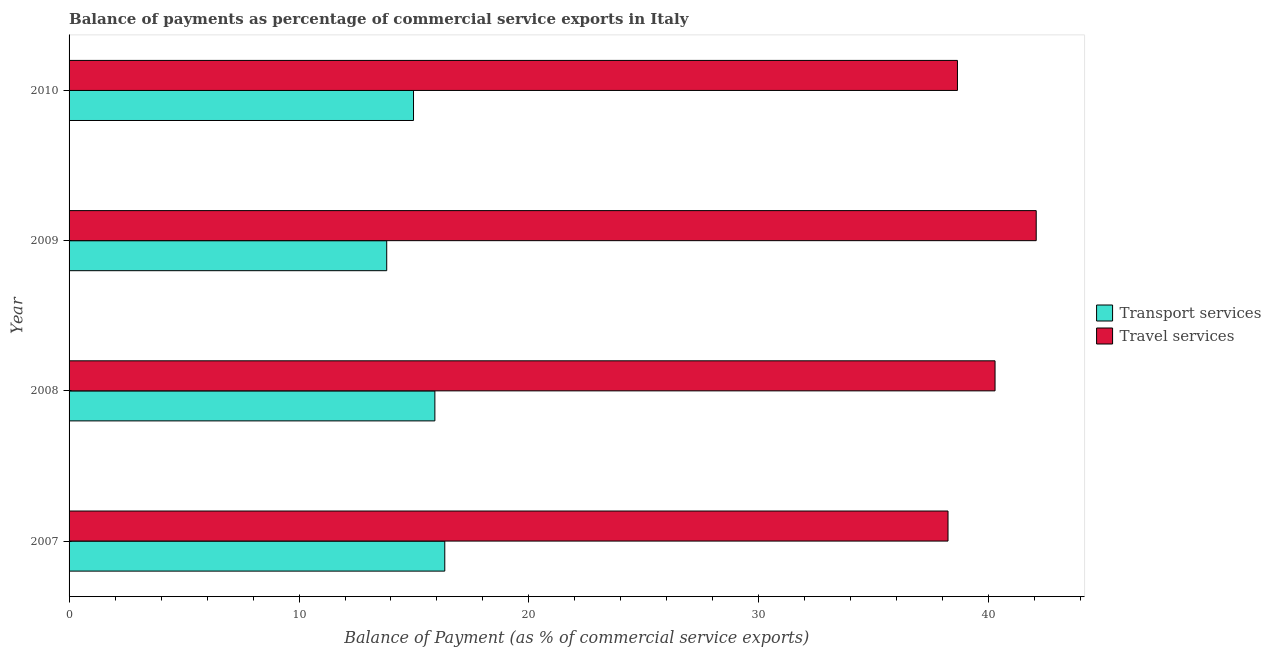How many different coloured bars are there?
Your answer should be compact. 2. How many groups of bars are there?
Your answer should be compact. 4. Are the number of bars per tick equal to the number of legend labels?
Your response must be concise. Yes. How many bars are there on the 2nd tick from the top?
Your answer should be compact. 2. How many bars are there on the 3rd tick from the bottom?
Provide a succinct answer. 2. What is the label of the 1st group of bars from the top?
Keep it short and to the point. 2010. What is the balance of payments of transport services in 2008?
Provide a short and direct response. 15.91. Across all years, what is the maximum balance of payments of travel services?
Provide a short and direct response. 42.06. Across all years, what is the minimum balance of payments of travel services?
Your answer should be compact. 38.22. What is the total balance of payments of travel services in the graph?
Give a very brief answer. 159.19. What is the difference between the balance of payments of transport services in 2007 and that in 2009?
Provide a short and direct response. 2.52. What is the difference between the balance of payments of travel services in 2008 and the balance of payments of transport services in 2007?
Your response must be concise. 23.93. What is the average balance of payments of transport services per year?
Make the answer very short. 15.26. In the year 2009, what is the difference between the balance of payments of travel services and balance of payments of transport services?
Provide a short and direct response. 28.25. In how many years, is the balance of payments of travel services greater than 6 %?
Offer a very short reply. 4. What is the ratio of the balance of payments of transport services in 2007 to that in 2009?
Make the answer very short. 1.18. What is the difference between the highest and the second highest balance of payments of travel services?
Offer a very short reply. 1.79. What is the difference between the highest and the lowest balance of payments of transport services?
Ensure brevity in your answer.  2.53. What does the 2nd bar from the top in 2010 represents?
Your answer should be compact. Transport services. What does the 1st bar from the bottom in 2010 represents?
Provide a succinct answer. Transport services. How many years are there in the graph?
Your answer should be very brief. 4. What is the difference between two consecutive major ticks on the X-axis?
Ensure brevity in your answer.  10. Are the values on the major ticks of X-axis written in scientific E-notation?
Ensure brevity in your answer.  No. Does the graph contain grids?
Your answer should be compact. No. Where does the legend appear in the graph?
Give a very brief answer. Center right. How are the legend labels stacked?
Provide a succinct answer. Vertical. What is the title of the graph?
Give a very brief answer. Balance of payments as percentage of commercial service exports in Italy. Does "Travel Items" appear as one of the legend labels in the graph?
Offer a terse response. No. What is the label or title of the X-axis?
Offer a very short reply. Balance of Payment (as % of commercial service exports). What is the label or title of the Y-axis?
Offer a very short reply. Year. What is the Balance of Payment (as % of commercial service exports) of Transport services in 2007?
Provide a short and direct response. 16.34. What is the Balance of Payment (as % of commercial service exports) in Travel services in 2007?
Your answer should be compact. 38.22. What is the Balance of Payment (as % of commercial service exports) of Transport services in 2008?
Make the answer very short. 15.91. What is the Balance of Payment (as % of commercial service exports) in Travel services in 2008?
Keep it short and to the point. 40.27. What is the Balance of Payment (as % of commercial service exports) of Transport services in 2009?
Ensure brevity in your answer.  13.81. What is the Balance of Payment (as % of commercial service exports) in Travel services in 2009?
Offer a terse response. 42.06. What is the Balance of Payment (as % of commercial service exports) of Transport services in 2010?
Make the answer very short. 14.98. What is the Balance of Payment (as % of commercial service exports) of Travel services in 2010?
Your response must be concise. 38.64. Across all years, what is the maximum Balance of Payment (as % of commercial service exports) of Transport services?
Provide a short and direct response. 16.34. Across all years, what is the maximum Balance of Payment (as % of commercial service exports) of Travel services?
Your response must be concise. 42.06. Across all years, what is the minimum Balance of Payment (as % of commercial service exports) of Transport services?
Provide a succinct answer. 13.81. Across all years, what is the minimum Balance of Payment (as % of commercial service exports) of Travel services?
Offer a very short reply. 38.22. What is the total Balance of Payment (as % of commercial service exports) of Transport services in the graph?
Provide a succinct answer. 61.04. What is the total Balance of Payment (as % of commercial service exports) in Travel services in the graph?
Your response must be concise. 159.19. What is the difference between the Balance of Payment (as % of commercial service exports) in Transport services in 2007 and that in 2008?
Your answer should be compact. 0.43. What is the difference between the Balance of Payment (as % of commercial service exports) of Travel services in 2007 and that in 2008?
Provide a short and direct response. -2.05. What is the difference between the Balance of Payment (as % of commercial service exports) of Transport services in 2007 and that in 2009?
Make the answer very short. 2.53. What is the difference between the Balance of Payment (as % of commercial service exports) of Travel services in 2007 and that in 2009?
Make the answer very short. -3.84. What is the difference between the Balance of Payment (as % of commercial service exports) in Transport services in 2007 and that in 2010?
Your answer should be compact. 1.36. What is the difference between the Balance of Payment (as % of commercial service exports) of Travel services in 2007 and that in 2010?
Your response must be concise. -0.41. What is the difference between the Balance of Payment (as % of commercial service exports) in Transport services in 2008 and that in 2009?
Ensure brevity in your answer.  2.09. What is the difference between the Balance of Payment (as % of commercial service exports) in Travel services in 2008 and that in 2009?
Your answer should be very brief. -1.79. What is the difference between the Balance of Payment (as % of commercial service exports) in Transport services in 2008 and that in 2010?
Make the answer very short. 0.93. What is the difference between the Balance of Payment (as % of commercial service exports) in Travel services in 2008 and that in 2010?
Give a very brief answer. 1.63. What is the difference between the Balance of Payment (as % of commercial service exports) of Transport services in 2009 and that in 2010?
Provide a short and direct response. -1.17. What is the difference between the Balance of Payment (as % of commercial service exports) of Travel services in 2009 and that in 2010?
Offer a very short reply. 3.42. What is the difference between the Balance of Payment (as % of commercial service exports) in Transport services in 2007 and the Balance of Payment (as % of commercial service exports) in Travel services in 2008?
Offer a terse response. -23.93. What is the difference between the Balance of Payment (as % of commercial service exports) in Transport services in 2007 and the Balance of Payment (as % of commercial service exports) in Travel services in 2009?
Make the answer very short. -25.72. What is the difference between the Balance of Payment (as % of commercial service exports) in Transport services in 2007 and the Balance of Payment (as % of commercial service exports) in Travel services in 2010?
Your answer should be very brief. -22.3. What is the difference between the Balance of Payment (as % of commercial service exports) of Transport services in 2008 and the Balance of Payment (as % of commercial service exports) of Travel services in 2009?
Offer a terse response. -26.15. What is the difference between the Balance of Payment (as % of commercial service exports) of Transport services in 2008 and the Balance of Payment (as % of commercial service exports) of Travel services in 2010?
Your answer should be very brief. -22.73. What is the difference between the Balance of Payment (as % of commercial service exports) in Transport services in 2009 and the Balance of Payment (as % of commercial service exports) in Travel services in 2010?
Provide a succinct answer. -24.82. What is the average Balance of Payment (as % of commercial service exports) of Transport services per year?
Make the answer very short. 15.26. What is the average Balance of Payment (as % of commercial service exports) of Travel services per year?
Give a very brief answer. 39.8. In the year 2007, what is the difference between the Balance of Payment (as % of commercial service exports) of Transport services and Balance of Payment (as % of commercial service exports) of Travel services?
Ensure brevity in your answer.  -21.89. In the year 2008, what is the difference between the Balance of Payment (as % of commercial service exports) in Transport services and Balance of Payment (as % of commercial service exports) in Travel services?
Provide a short and direct response. -24.36. In the year 2009, what is the difference between the Balance of Payment (as % of commercial service exports) in Transport services and Balance of Payment (as % of commercial service exports) in Travel services?
Provide a short and direct response. -28.25. In the year 2010, what is the difference between the Balance of Payment (as % of commercial service exports) in Transport services and Balance of Payment (as % of commercial service exports) in Travel services?
Your answer should be compact. -23.66. What is the ratio of the Balance of Payment (as % of commercial service exports) in Transport services in 2007 to that in 2008?
Your response must be concise. 1.03. What is the ratio of the Balance of Payment (as % of commercial service exports) in Travel services in 2007 to that in 2008?
Ensure brevity in your answer.  0.95. What is the ratio of the Balance of Payment (as % of commercial service exports) of Transport services in 2007 to that in 2009?
Keep it short and to the point. 1.18. What is the ratio of the Balance of Payment (as % of commercial service exports) of Travel services in 2007 to that in 2009?
Ensure brevity in your answer.  0.91. What is the ratio of the Balance of Payment (as % of commercial service exports) in Transport services in 2007 to that in 2010?
Provide a succinct answer. 1.09. What is the ratio of the Balance of Payment (as % of commercial service exports) in Travel services in 2007 to that in 2010?
Provide a succinct answer. 0.99. What is the ratio of the Balance of Payment (as % of commercial service exports) in Transport services in 2008 to that in 2009?
Ensure brevity in your answer.  1.15. What is the ratio of the Balance of Payment (as % of commercial service exports) of Travel services in 2008 to that in 2009?
Ensure brevity in your answer.  0.96. What is the ratio of the Balance of Payment (as % of commercial service exports) of Transport services in 2008 to that in 2010?
Ensure brevity in your answer.  1.06. What is the ratio of the Balance of Payment (as % of commercial service exports) in Travel services in 2008 to that in 2010?
Offer a very short reply. 1.04. What is the ratio of the Balance of Payment (as % of commercial service exports) in Transport services in 2009 to that in 2010?
Provide a succinct answer. 0.92. What is the ratio of the Balance of Payment (as % of commercial service exports) in Travel services in 2009 to that in 2010?
Your answer should be very brief. 1.09. What is the difference between the highest and the second highest Balance of Payment (as % of commercial service exports) of Transport services?
Offer a very short reply. 0.43. What is the difference between the highest and the second highest Balance of Payment (as % of commercial service exports) of Travel services?
Your answer should be compact. 1.79. What is the difference between the highest and the lowest Balance of Payment (as % of commercial service exports) of Transport services?
Your response must be concise. 2.53. What is the difference between the highest and the lowest Balance of Payment (as % of commercial service exports) in Travel services?
Keep it short and to the point. 3.84. 